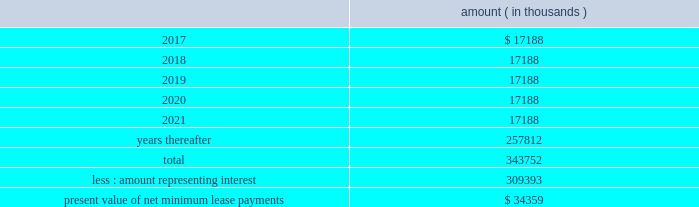Entergy corporation and subsidiaries notes to financial statements liability to $ 60 million , and recorded the $ 2.7 million difference as a credit to interest expense .
The $ 60 million remaining liability was eliminated upon payment of the cash portion of the purchase price .
As of december 31 , 2016 , entergy louisiana , in connection with the waterford 3 lease obligation , had a future minimum lease payment ( reflecting an interest rate of 8.09% ( 8.09 % ) ) of $ 57.5 million , including $ 2.3 million in interest , due january 2017 that is recorded as long-term debt .
In february 2017 the leases were terminated and the leased assets were conveyed to entergy louisiana .
Grand gulf lease obligations in 1988 , in two separate but substantially identical transactions , system energy sold and leased back undivided ownership interests in grand gulf for the aggregate sum of $ 500 million .
The initial term of the leases expired in july 2015 .
System energy renewed the leases for fair market value with renewal terms expiring in july 2036 .
At the end of the new lease renewal terms , system energy has the option to repurchase the leased interests in grand gulf or renew the leases at fair market value .
In the event that system energy does not renew or purchase the interests , system energy would surrender such interests and their associated entitlement of grand gulf 2019s capacity and energy .
System energy is required to report the sale-leaseback as a financing transaction in its financial statements .
For financial reporting purposes , system energy expenses the interest portion of the lease obligation and the plant depreciation .
However , operating revenues include the recovery of the lease payments because the transactions are accounted for as a sale and leaseback for ratemaking purposes .
Consistent with a recommendation contained in a ferc audit report , system energy initially recorded as a net regulatory asset the difference between the recovery of the lease payments and the amounts expensed for interest and depreciation and continues to record this difference as a regulatory asset or liability on an ongoing basis , resulting in a zero net balance for the regulatory asset at the end of the lease term .
The amount was a net regulatory liability of $ 55.6 million and $ 55.6 million as of december 31 , 2016 and 2015 , respectively .
As of december 31 , 2016 , system energy , in connection with the grand gulf sale and leaseback transactions , had future minimum lease payments ( reflecting an implicit rate of 5.13% ( 5.13 % ) ) that are recorded as long-term debt , as follows : amount ( in thousands ) .

What portion of the total future minimum lease payments is used for interest in connection with the grand gulf sale and leaseback transactions? 
Computations: (309393 / 343752)
Answer: 0.90005. 